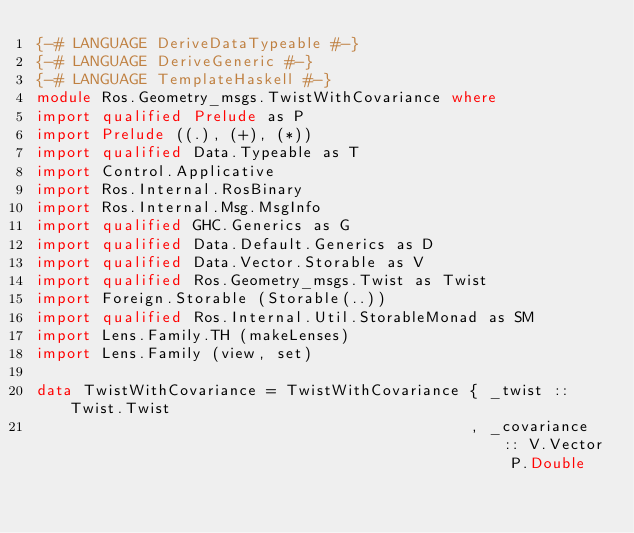Convert code to text. <code><loc_0><loc_0><loc_500><loc_500><_Haskell_>{-# LANGUAGE DeriveDataTypeable #-}
{-# LANGUAGE DeriveGeneric #-}
{-# LANGUAGE TemplateHaskell #-}
module Ros.Geometry_msgs.TwistWithCovariance where
import qualified Prelude as P
import Prelude ((.), (+), (*))
import qualified Data.Typeable as T
import Control.Applicative
import Ros.Internal.RosBinary
import Ros.Internal.Msg.MsgInfo
import qualified GHC.Generics as G
import qualified Data.Default.Generics as D
import qualified Data.Vector.Storable as V
import qualified Ros.Geometry_msgs.Twist as Twist
import Foreign.Storable (Storable(..))
import qualified Ros.Internal.Util.StorableMonad as SM
import Lens.Family.TH (makeLenses)
import Lens.Family (view, set)

data TwistWithCovariance = TwistWithCovariance { _twist :: Twist.Twist
                                               , _covariance :: V.Vector P.Double</code> 